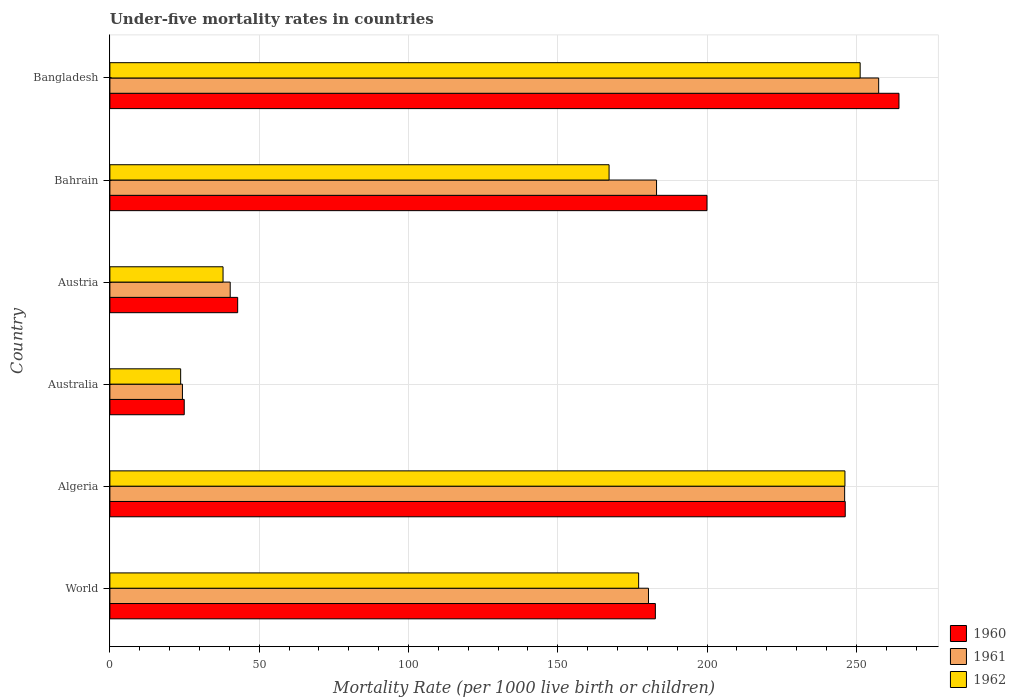Are the number of bars per tick equal to the number of legend labels?
Ensure brevity in your answer.  Yes. How many bars are there on the 3rd tick from the top?
Give a very brief answer. 3. How many bars are there on the 4th tick from the bottom?
Offer a very short reply. 3. Across all countries, what is the maximum under-five mortality rate in 1960?
Provide a succinct answer. 264.3. Across all countries, what is the minimum under-five mortality rate in 1960?
Provide a succinct answer. 24.9. In which country was the under-five mortality rate in 1962 minimum?
Your response must be concise. Australia. What is the total under-five mortality rate in 1960 in the graph?
Keep it short and to the point. 961. What is the difference between the under-five mortality rate in 1962 in Algeria and that in Austria?
Your answer should be very brief. 208.3. What is the difference between the under-five mortality rate in 1960 in Bahrain and the under-five mortality rate in 1962 in World?
Offer a very short reply. 22.9. What is the average under-five mortality rate in 1961 per country?
Your answer should be very brief. 155.28. What is the difference between the under-five mortality rate in 1961 and under-five mortality rate in 1962 in Austria?
Your answer should be very brief. 2.4. What is the ratio of the under-five mortality rate in 1961 in Algeria to that in World?
Make the answer very short. 1.36. Is the difference between the under-five mortality rate in 1961 in Algeria and Austria greater than the difference between the under-five mortality rate in 1962 in Algeria and Austria?
Your answer should be compact. No. What is the difference between the highest and the second highest under-five mortality rate in 1961?
Keep it short and to the point. 11.4. What is the difference between the highest and the lowest under-five mortality rate in 1961?
Offer a very short reply. 233.2. What does the 3rd bar from the top in Algeria represents?
Provide a succinct answer. 1960. What does the 3rd bar from the bottom in Australia represents?
Provide a short and direct response. 1962. Is it the case that in every country, the sum of the under-five mortality rate in 1960 and under-five mortality rate in 1961 is greater than the under-five mortality rate in 1962?
Offer a very short reply. Yes. How many countries are there in the graph?
Keep it short and to the point. 6. Are the values on the major ticks of X-axis written in scientific E-notation?
Make the answer very short. No. Does the graph contain any zero values?
Give a very brief answer. No. What is the title of the graph?
Make the answer very short. Under-five mortality rates in countries. Does "1962" appear as one of the legend labels in the graph?
Make the answer very short. Yes. What is the label or title of the X-axis?
Offer a terse response. Mortality Rate (per 1000 live birth or children). What is the Mortality Rate (per 1000 live birth or children) of 1960 in World?
Your response must be concise. 182.7. What is the Mortality Rate (per 1000 live birth or children) of 1961 in World?
Make the answer very short. 180.4. What is the Mortality Rate (per 1000 live birth or children) in 1962 in World?
Make the answer very short. 177.1. What is the Mortality Rate (per 1000 live birth or children) in 1960 in Algeria?
Make the answer very short. 246.3. What is the Mortality Rate (per 1000 live birth or children) of 1961 in Algeria?
Keep it short and to the point. 246.1. What is the Mortality Rate (per 1000 live birth or children) in 1962 in Algeria?
Your answer should be very brief. 246.2. What is the Mortality Rate (per 1000 live birth or children) of 1960 in Australia?
Give a very brief answer. 24.9. What is the Mortality Rate (per 1000 live birth or children) of 1961 in Australia?
Your answer should be very brief. 24.3. What is the Mortality Rate (per 1000 live birth or children) of 1962 in Australia?
Offer a terse response. 23.7. What is the Mortality Rate (per 1000 live birth or children) in 1960 in Austria?
Ensure brevity in your answer.  42.8. What is the Mortality Rate (per 1000 live birth or children) of 1961 in Austria?
Make the answer very short. 40.3. What is the Mortality Rate (per 1000 live birth or children) in 1962 in Austria?
Keep it short and to the point. 37.9. What is the Mortality Rate (per 1000 live birth or children) of 1961 in Bahrain?
Your answer should be very brief. 183.1. What is the Mortality Rate (per 1000 live birth or children) in 1962 in Bahrain?
Make the answer very short. 167.2. What is the Mortality Rate (per 1000 live birth or children) of 1960 in Bangladesh?
Provide a short and direct response. 264.3. What is the Mortality Rate (per 1000 live birth or children) of 1961 in Bangladesh?
Keep it short and to the point. 257.5. What is the Mortality Rate (per 1000 live birth or children) in 1962 in Bangladesh?
Give a very brief answer. 251.3. Across all countries, what is the maximum Mortality Rate (per 1000 live birth or children) in 1960?
Keep it short and to the point. 264.3. Across all countries, what is the maximum Mortality Rate (per 1000 live birth or children) in 1961?
Provide a succinct answer. 257.5. Across all countries, what is the maximum Mortality Rate (per 1000 live birth or children) of 1962?
Keep it short and to the point. 251.3. Across all countries, what is the minimum Mortality Rate (per 1000 live birth or children) of 1960?
Offer a very short reply. 24.9. Across all countries, what is the minimum Mortality Rate (per 1000 live birth or children) of 1961?
Your answer should be very brief. 24.3. Across all countries, what is the minimum Mortality Rate (per 1000 live birth or children) in 1962?
Give a very brief answer. 23.7. What is the total Mortality Rate (per 1000 live birth or children) of 1960 in the graph?
Offer a very short reply. 961. What is the total Mortality Rate (per 1000 live birth or children) in 1961 in the graph?
Provide a succinct answer. 931.7. What is the total Mortality Rate (per 1000 live birth or children) in 1962 in the graph?
Your answer should be compact. 903.4. What is the difference between the Mortality Rate (per 1000 live birth or children) in 1960 in World and that in Algeria?
Ensure brevity in your answer.  -63.6. What is the difference between the Mortality Rate (per 1000 live birth or children) in 1961 in World and that in Algeria?
Keep it short and to the point. -65.7. What is the difference between the Mortality Rate (per 1000 live birth or children) of 1962 in World and that in Algeria?
Your answer should be very brief. -69.1. What is the difference between the Mortality Rate (per 1000 live birth or children) in 1960 in World and that in Australia?
Keep it short and to the point. 157.8. What is the difference between the Mortality Rate (per 1000 live birth or children) in 1961 in World and that in Australia?
Your answer should be very brief. 156.1. What is the difference between the Mortality Rate (per 1000 live birth or children) in 1962 in World and that in Australia?
Give a very brief answer. 153.4. What is the difference between the Mortality Rate (per 1000 live birth or children) in 1960 in World and that in Austria?
Offer a very short reply. 139.9. What is the difference between the Mortality Rate (per 1000 live birth or children) in 1961 in World and that in Austria?
Your response must be concise. 140.1. What is the difference between the Mortality Rate (per 1000 live birth or children) of 1962 in World and that in Austria?
Keep it short and to the point. 139.2. What is the difference between the Mortality Rate (per 1000 live birth or children) in 1960 in World and that in Bahrain?
Offer a very short reply. -17.3. What is the difference between the Mortality Rate (per 1000 live birth or children) of 1960 in World and that in Bangladesh?
Make the answer very short. -81.6. What is the difference between the Mortality Rate (per 1000 live birth or children) of 1961 in World and that in Bangladesh?
Keep it short and to the point. -77.1. What is the difference between the Mortality Rate (per 1000 live birth or children) in 1962 in World and that in Bangladesh?
Make the answer very short. -74.2. What is the difference between the Mortality Rate (per 1000 live birth or children) in 1960 in Algeria and that in Australia?
Keep it short and to the point. 221.4. What is the difference between the Mortality Rate (per 1000 live birth or children) of 1961 in Algeria and that in Australia?
Give a very brief answer. 221.8. What is the difference between the Mortality Rate (per 1000 live birth or children) of 1962 in Algeria and that in Australia?
Give a very brief answer. 222.5. What is the difference between the Mortality Rate (per 1000 live birth or children) in 1960 in Algeria and that in Austria?
Give a very brief answer. 203.5. What is the difference between the Mortality Rate (per 1000 live birth or children) of 1961 in Algeria and that in Austria?
Ensure brevity in your answer.  205.8. What is the difference between the Mortality Rate (per 1000 live birth or children) in 1962 in Algeria and that in Austria?
Give a very brief answer. 208.3. What is the difference between the Mortality Rate (per 1000 live birth or children) in 1960 in Algeria and that in Bahrain?
Your answer should be very brief. 46.3. What is the difference between the Mortality Rate (per 1000 live birth or children) in 1962 in Algeria and that in Bahrain?
Ensure brevity in your answer.  79. What is the difference between the Mortality Rate (per 1000 live birth or children) in 1961 in Algeria and that in Bangladesh?
Offer a very short reply. -11.4. What is the difference between the Mortality Rate (per 1000 live birth or children) of 1962 in Algeria and that in Bangladesh?
Offer a terse response. -5.1. What is the difference between the Mortality Rate (per 1000 live birth or children) in 1960 in Australia and that in Austria?
Offer a very short reply. -17.9. What is the difference between the Mortality Rate (per 1000 live birth or children) in 1962 in Australia and that in Austria?
Provide a short and direct response. -14.2. What is the difference between the Mortality Rate (per 1000 live birth or children) in 1960 in Australia and that in Bahrain?
Make the answer very short. -175.1. What is the difference between the Mortality Rate (per 1000 live birth or children) in 1961 in Australia and that in Bahrain?
Your answer should be very brief. -158.8. What is the difference between the Mortality Rate (per 1000 live birth or children) in 1962 in Australia and that in Bahrain?
Your response must be concise. -143.5. What is the difference between the Mortality Rate (per 1000 live birth or children) in 1960 in Australia and that in Bangladesh?
Your answer should be very brief. -239.4. What is the difference between the Mortality Rate (per 1000 live birth or children) of 1961 in Australia and that in Bangladesh?
Keep it short and to the point. -233.2. What is the difference between the Mortality Rate (per 1000 live birth or children) in 1962 in Australia and that in Bangladesh?
Make the answer very short. -227.6. What is the difference between the Mortality Rate (per 1000 live birth or children) in 1960 in Austria and that in Bahrain?
Your answer should be very brief. -157.2. What is the difference between the Mortality Rate (per 1000 live birth or children) of 1961 in Austria and that in Bahrain?
Keep it short and to the point. -142.8. What is the difference between the Mortality Rate (per 1000 live birth or children) of 1962 in Austria and that in Bahrain?
Your answer should be compact. -129.3. What is the difference between the Mortality Rate (per 1000 live birth or children) of 1960 in Austria and that in Bangladesh?
Provide a short and direct response. -221.5. What is the difference between the Mortality Rate (per 1000 live birth or children) in 1961 in Austria and that in Bangladesh?
Give a very brief answer. -217.2. What is the difference between the Mortality Rate (per 1000 live birth or children) in 1962 in Austria and that in Bangladesh?
Ensure brevity in your answer.  -213.4. What is the difference between the Mortality Rate (per 1000 live birth or children) of 1960 in Bahrain and that in Bangladesh?
Offer a very short reply. -64.3. What is the difference between the Mortality Rate (per 1000 live birth or children) in 1961 in Bahrain and that in Bangladesh?
Give a very brief answer. -74.4. What is the difference between the Mortality Rate (per 1000 live birth or children) in 1962 in Bahrain and that in Bangladesh?
Ensure brevity in your answer.  -84.1. What is the difference between the Mortality Rate (per 1000 live birth or children) of 1960 in World and the Mortality Rate (per 1000 live birth or children) of 1961 in Algeria?
Your answer should be compact. -63.4. What is the difference between the Mortality Rate (per 1000 live birth or children) in 1960 in World and the Mortality Rate (per 1000 live birth or children) in 1962 in Algeria?
Your response must be concise. -63.5. What is the difference between the Mortality Rate (per 1000 live birth or children) in 1961 in World and the Mortality Rate (per 1000 live birth or children) in 1962 in Algeria?
Your answer should be very brief. -65.8. What is the difference between the Mortality Rate (per 1000 live birth or children) in 1960 in World and the Mortality Rate (per 1000 live birth or children) in 1961 in Australia?
Provide a short and direct response. 158.4. What is the difference between the Mortality Rate (per 1000 live birth or children) of 1960 in World and the Mortality Rate (per 1000 live birth or children) of 1962 in Australia?
Make the answer very short. 159. What is the difference between the Mortality Rate (per 1000 live birth or children) of 1961 in World and the Mortality Rate (per 1000 live birth or children) of 1962 in Australia?
Make the answer very short. 156.7. What is the difference between the Mortality Rate (per 1000 live birth or children) of 1960 in World and the Mortality Rate (per 1000 live birth or children) of 1961 in Austria?
Offer a very short reply. 142.4. What is the difference between the Mortality Rate (per 1000 live birth or children) of 1960 in World and the Mortality Rate (per 1000 live birth or children) of 1962 in Austria?
Give a very brief answer. 144.8. What is the difference between the Mortality Rate (per 1000 live birth or children) of 1961 in World and the Mortality Rate (per 1000 live birth or children) of 1962 in Austria?
Make the answer very short. 142.5. What is the difference between the Mortality Rate (per 1000 live birth or children) of 1960 in World and the Mortality Rate (per 1000 live birth or children) of 1961 in Bahrain?
Provide a succinct answer. -0.4. What is the difference between the Mortality Rate (per 1000 live birth or children) in 1961 in World and the Mortality Rate (per 1000 live birth or children) in 1962 in Bahrain?
Your answer should be very brief. 13.2. What is the difference between the Mortality Rate (per 1000 live birth or children) of 1960 in World and the Mortality Rate (per 1000 live birth or children) of 1961 in Bangladesh?
Your response must be concise. -74.8. What is the difference between the Mortality Rate (per 1000 live birth or children) in 1960 in World and the Mortality Rate (per 1000 live birth or children) in 1962 in Bangladesh?
Your answer should be compact. -68.6. What is the difference between the Mortality Rate (per 1000 live birth or children) of 1961 in World and the Mortality Rate (per 1000 live birth or children) of 1962 in Bangladesh?
Your answer should be very brief. -70.9. What is the difference between the Mortality Rate (per 1000 live birth or children) of 1960 in Algeria and the Mortality Rate (per 1000 live birth or children) of 1961 in Australia?
Provide a succinct answer. 222. What is the difference between the Mortality Rate (per 1000 live birth or children) of 1960 in Algeria and the Mortality Rate (per 1000 live birth or children) of 1962 in Australia?
Make the answer very short. 222.6. What is the difference between the Mortality Rate (per 1000 live birth or children) of 1961 in Algeria and the Mortality Rate (per 1000 live birth or children) of 1962 in Australia?
Your response must be concise. 222.4. What is the difference between the Mortality Rate (per 1000 live birth or children) of 1960 in Algeria and the Mortality Rate (per 1000 live birth or children) of 1961 in Austria?
Give a very brief answer. 206. What is the difference between the Mortality Rate (per 1000 live birth or children) in 1960 in Algeria and the Mortality Rate (per 1000 live birth or children) in 1962 in Austria?
Offer a terse response. 208.4. What is the difference between the Mortality Rate (per 1000 live birth or children) in 1961 in Algeria and the Mortality Rate (per 1000 live birth or children) in 1962 in Austria?
Keep it short and to the point. 208.2. What is the difference between the Mortality Rate (per 1000 live birth or children) of 1960 in Algeria and the Mortality Rate (per 1000 live birth or children) of 1961 in Bahrain?
Your answer should be compact. 63.2. What is the difference between the Mortality Rate (per 1000 live birth or children) of 1960 in Algeria and the Mortality Rate (per 1000 live birth or children) of 1962 in Bahrain?
Offer a terse response. 79.1. What is the difference between the Mortality Rate (per 1000 live birth or children) of 1961 in Algeria and the Mortality Rate (per 1000 live birth or children) of 1962 in Bahrain?
Your response must be concise. 78.9. What is the difference between the Mortality Rate (per 1000 live birth or children) in 1960 in Algeria and the Mortality Rate (per 1000 live birth or children) in 1961 in Bangladesh?
Your answer should be very brief. -11.2. What is the difference between the Mortality Rate (per 1000 live birth or children) in 1961 in Algeria and the Mortality Rate (per 1000 live birth or children) in 1962 in Bangladesh?
Your answer should be very brief. -5.2. What is the difference between the Mortality Rate (per 1000 live birth or children) of 1960 in Australia and the Mortality Rate (per 1000 live birth or children) of 1961 in Austria?
Ensure brevity in your answer.  -15.4. What is the difference between the Mortality Rate (per 1000 live birth or children) in 1960 in Australia and the Mortality Rate (per 1000 live birth or children) in 1961 in Bahrain?
Your answer should be compact. -158.2. What is the difference between the Mortality Rate (per 1000 live birth or children) in 1960 in Australia and the Mortality Rate (per 1000 live birth or children) in 1962 in Bahrain?
Offer a very short reply. -142.3. What is the difference between the Mortality Rate (per 1000 live birth or children) in 1961 in Australia and the Mortality Rate (per 1000 live birth or children) in 1962 in Bahrain?
Give a very brief answer. -142.9. What is the difference between the Mortality Rate (per 1000 live birth or children) in 1960 in Australia and the Mortality Rate (per 1000 live birth or children) in 1961 in Bangladesh?
Your response must be concise. -232.6. What is the difference between the Mortality Rate (per 1000 live birth or children) in 1960 in Australia and the Mortality Rate (per 1000 live birth or children) in 1962 in Bangladesh?
Provide a short and direct response. -226.4. What is the difference between the Mortality Rate (per 1000 live birth or children) of 1961 in Australia and the Mortality Rate (per 1000 live birth or children) of 1962 in Bangladesh?
Offer a very short reply. -227. What is the difference between the Mortality Rate (per 1000 live birth or children) in 1960 in Austria and the Mortality Rate (per 1000 live birth or children) in 1961 in Bahrain?
Provide a succinct answer. -140.3. What is the difference between the Mortality Rate (per 1000 live birth or children) in 1960 in Austria and the Mortality Rate (per 1000 live birth or children) in 1962 in Bahrain?
Ensure brevity in your answer.  -124.4. What is the difference between the Mortality Rate (per 1000 live birth or children) of 1961 in Austria and the Mortality Rate (per 1000 live birth or children) of 1962 in Bahrain?
Your response must be concise. -126.9. What is the difference between the Mortality Rate (per 1000 live birth or children) in 1960 in Austria and the Mortality Rate (per 1000 live birth or children) in 1961 in Bangladesh?
Offer a very short reply. -214.7. What is the difference between the Mortality Rate (per 1000 live birth or children) of 1960 in Austria and the Mortality Rate (per 1000 live birth or children) of 1962 in Bangladesh?
Offer a terse response. -208.5. What is the difference between the Mortality Rate (per 1000 live birth or children) in 1961 in Austria and the Mortality Rate (per 1000 live birth or children) in 1962 in Bangladesh?
Keep it short and to the point. -211. What is the difference between the Mortality Rate (per 1000 live birth or children) in 1960 in Bahrain and the Mortality Rate (per 1000 live birth or children) in 1961 in Bangladesh?
Give a very brief answer. -57.5. What is the difference between the Mortality Rate (per 1000 live birth or children) of 1960 in Bahrain and the Mortality Rate (per 1000 live birth or children) of 1962 in Bangladesh?
Give a very brief answer. -51.3. What is the difference between the Mortality Rate (per 1000 live birth or children) of 1961 in Bahrain and the Mortality Rate (per 1000 live birth or children) of 1962 in Bangladesh?
Your answer should be compact. -68.2. What is the average Mortality Rate (per 1000 live birth or children) in 1960 per country?
Provide a succinct answer. 160.17. What is the average Mortality Rate (per 1000 live birth or children) in 1961 per country?
Keep it short and to the point. 155.28. What is the average Mortality Rate (per 1000 live birth or children) in 1962 per country?
Give a very brief answer. 150.57. What is the difference between the Mortality Rate (per 1000 live birth or children) in 1960 and Mortality Rate (per 1000 live birth or children) in 1962 in World?
Keep it short and to the point. 5.6. What is the difference between the Mortality Rate (per 1000 live birth or children) of 1961 and Mortality Rate (per 1000 live birth or children) of 1962 in World?
Ensure brevity in your answer.  3.3. What is the difference between the Mortality Rate (per 1000 live birth or children) of 1960 and Mortality Rate (per 1000 live birth or children) of 1961 in Algeria?
Your response must be concise. 0.2. What is the difference between the Mortality Rate (per 1000 live birth or children) in 1960 and Mortality Rate (per 1000 live birth or children) in 1962 in Australia?
Your answer should be compact. 1.2. What is the difference between the Mortality Rate (per 1000 live birth or children) of 1960 and Mortality Rate (per 1000 live birth or children) of 1961 in Austria?
Your response must be concise. 2.5. What is the difference between the Mortality Rate (per 1000 live birth or children) of 1961 and Mortality Rate (per 1000 live birth or children) of 1962 in Austria?
Make the answer very short. 2.4. What is the difference between the Mortality Rate (per 1000 live birth or children) of 1960 and Mortality Rate (per 1000 live birth or children) of 1961 in Bahrain?
Make the answer very short. 16.9. What is the difference between the Mortality Rate (per 1000 live birth or children) of 1960 and Mortality Rate (per 1000 live birth or children) of 1962 in Bahrain?
Give a very brief answer. 32.8. What is the difference between the Mortality Rate (per 1000 live birth or children) of 1960 and Mortality Rate (per 1000 live birth or children) of 1961 in Bangladesh?
Your answer should be compact. 6.8. What is the ratio of the Mortality Rate (per 1000 live birth or children) in 1960 in World to that in Algeria?
Your answer should be very brief. 0.74. What is the ratio of the Mortality Rate (per 1000 live birth or children) in 1961 in World to that in Algeria?
Your response must be concise. 0.73. What is the ratio of the Mortality Rate (per 1000 live birth or children) of 1962 in World to that in Algeria?
Give a very brief answer. 0.72. What is the ratio of the Mortality Rate (per 1000 live birth or children) of 1960 in World to that in Australia?
Your response must be concise. 7.34. What is the ratio of the Mortality Rate (per 1000 live birth or children) of 1961 in World to that in Australia?
Your response must be concise. 7.42. What is the ratio of the Mortality Rate (per 1000 live birth or children) of 1962 in World to that in Australia?
Ensure brevity in your answer.  7.47. What is the ratio of the Mortality Rate (per 1000 live birth or children) in 1960 in World to that in Austria?
Offer a terse response. 4.27. What is the ratio of the Mortality Rate (per 1000 live birth or children) of 1961 in World to that in Austria?
Give a very brief answer. 4.48. What is the ratio of the Mortality Rate (per 1000 live birth or children) in 1962 in World to that in Austria?
Your response must be concise. 4.67. What is the ratio of the Mortality Rate (per 1000 live birth or children) of 1960 in World to that in Bahrain?
Offer a terse response. 0.91. What is the ratio of the Mortality Rate (per 1000 live birth or children) in 1961 in World to that in Bahrain?
Your response must be concise. 0.99. What is the ratio of the Mortality Rate (per 1000 live birth or children) in 1962 in World to that in Bahrain?
Offer a very short reply. 1.06. What is the ratio of the Mortality Rate (per 1000 live birth or children) of 1960 in World to that in Bangladesh?
Give a very brief answer. 0.69. What is the ratio of the Mortality Rate (per 1000 live birth or children) of 1961 in World to that in Bangladesh?
Keep it short and to the point. 0.7. What is the ratio of the Mortality Rate (per 1000 live birth or children) of 1962 in World to that in Bangladesh?
Provide a succinct answer. 0.7. What is the ratio of the Mortality Rate (per 1000 live birth or children) of 1960 in Algeria to that in Australia?
Provide a succinct answer. 9.89. What is the ratio of the Mortality Rate (per 1000 live birth or children) of 1961 in Algeria to that in Australia?
Give a very brief answer. 10.13. What is the ratio of the Mortality Rate (per 1000 live birth or children) of 1962 in Algeria to that in Australia?
Offer a terse response. 10.39. What is the ratio of the Mortality Rate (per 1000 live birth or children) of 1960 in Algeria to that in Austria?
Keep it short and to the point. 5.75. What is the ratio of the Mortality Rate (per 1000 live birth or children) in 1961 in Algeria to that in Austria?
Your answer should be compact. 6.11. What is the ratio of the Mortality Rate (per 1000 live birth or children) in 1962 in Algeria to that in Austria?
Provide a short and direct response. 6.5. What is the ratio of the Mortality Rate (per 1000 live birth or children) in 1960 in Algeria to that in Bahrain?
Offer a terse response. 1.23. What is the ratio of the Mortality Rate (per 1000 live birth or children) in 1961 in Algeria to that in Bahrain?
Your answer should be very brief. 1.34. What is the ratio of the Mortality Rate (per 1000 live birth or children) of 1962 in Algeria to that in Bahrain?
Provide a short and direct response. 1.47. What is the ratio of the Mortality Rate (per 1000 live birth or children) of 1960 in Algeria to that in Bangladesh?
Offer a terse response. 0.93. What is the ratio of the Mortality Rate (per 1000 live birth or children) in 1961 in Algeria to that in Bangladesh?
Give a very brief answer. 0.96. What is the ratio of the Mortality Rate (per 1000 live birth or children) of 1962 in Algeria to that in Bangladesh?
Offer a terse response. 0.98. What is the ratio of the Mortality Rate (per 1000 live birth or children) of 1960 in Australia to that in Austria?
Keep it short and to the point. 0.58. What is the ratio of the Mortality Rate (per 1000 live birth or children) in 1961 in Australia to that in Austria?
Give a very brief answer. 0.6. What is the ratio of the Mortality Rate (per 1000 live birth or children) of 1962 in Australia to that in Austria?
Ensure brevity in your answer.  0.63. What is the ratio of the Mortality Rate (per 1000 live birth or children) in 1960 in Australia to that in Bahrain?
Offer a very short reply. 0.12. What is the ratio of the Mortality Rate (per 1000 live birth or children) in 1961 in Australia to that in Bahrain?
Make the answer very short. 0.13. What is the ratio of the Mortality Rate (per 1000 live birth or children) in 1962 in Australia to that in Bahrain?
Make the answer very short. 0.14. What is the ratio of the Mortality Rate (per 1000 live birth or children) of 1960 in Australia to that in Bangladesh?
Offer a very short reply. 0.09. What is the ratio of the Mortality Rate (per 1000 live birth or children) of 1961 in Australia to that in Bangladesh?
Offer a terse response. 0.09. What is the ratio of the Mortality Rate (per 1000 live birth or children) in 1962 in Australia to that in Bangladesh?
Your answer should be very brief. 0.09. What is the ratio of the Mortality Rate (per 1000 live birth or children) of 1960 in Austria to that in Bahrain?
Give a very brief answer. 0.21. What is the ratio of the Mortality Rate (per 1000 live birth or children) in 1961 in Austria to that in Bahrain?
Offer a very short reply. 0.22. What is the ratio of the Mortality Rate (per 1000 live birth or children) of 1962 in Austria to that in Bahrain?
Ensure brevity in your answer.  0.23. What is the ratio of the Mortality Rate (per 1000 live birth or children) of 1960 in Austria to that in Bangladesh?
Make the answer very short. 0.16. What is the ratio of the Mortality Rate (per 1000 live birth or children) in 1961 in Austria to that in Bangladesh?
Offer a very short reply. 0.16. What is the ratio of the Mortality Rate (per 1000 live birth or children) in 1962 in Austria to that in Bangladesh?
Ensure brevity in your answer.  0.15. What is the ratio of the Mortality Rate (per 1000 live birth or children) of 1960 in Bahrain to that in Bangladesh?
Keep it short and to the point. 0.76. What is the ratio of the Mortality Rate (per 1000 live birth or children) in 1961 in Bahrain to that in Bangladesh?
Offer a terse response. 0.71. What is the ratio of the Mortality Rate (per 1000 live birth or children) of 1962 in Bahrain to that in Bangladesh?
Give a very brief answer. 0.67. What is the difference between the highest and the second highest Mortality Rate (per 1000 live birth or children) in 1960?
Offer a very short reply. 18. What is the difference between the highest and the second highest Mortality Rate (per 1000 live birth or children) of 1962?
Keep it short and to the point. 5.1. What is the difference between the highest and the lowest Mortality Rate (per 1000 live birth or children) in 1960?
Provide a succinct answer. 239.4. What is the difference between the highest and the lowest Mortality Rate (per 1000 live birth or children) in 1961?
Give a very brief answer. 233.2. What is the difference between the highest and the lowest Mortality Rate (per 1000 live birth or children) in 1962?
Your response must be concise. 227.6. 